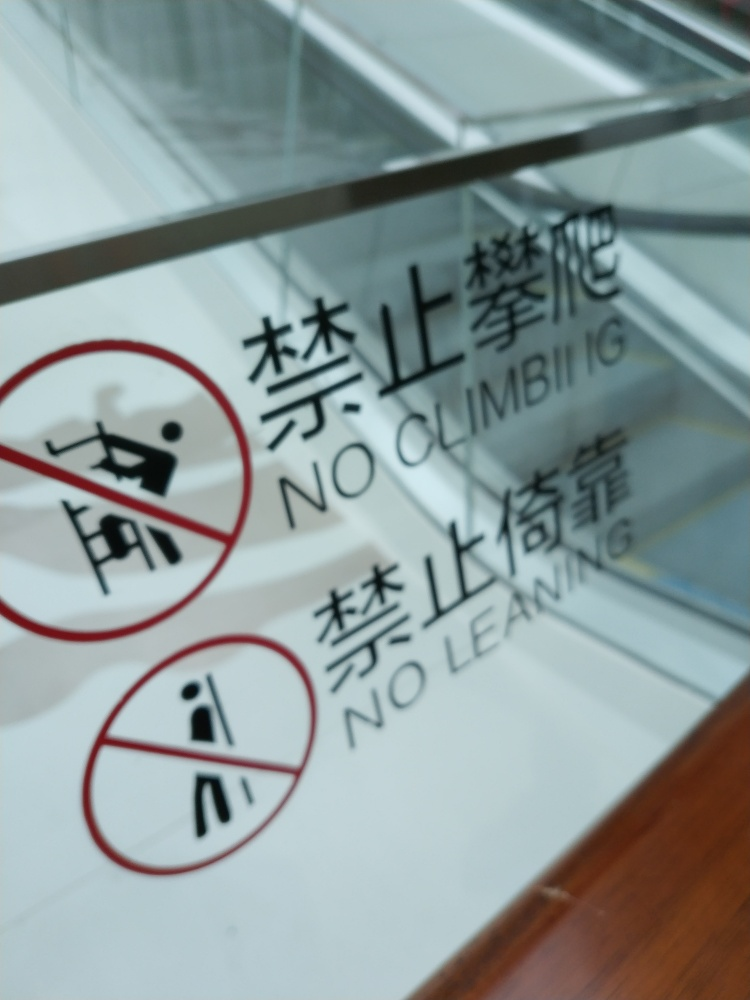How does the blurry quality of the photo affect the message of the sign? Despite the blurriness, the message of the sign remains clear due to the boldness and simplicity of the pictograms. Such designs are meant to be quickly understood at a glance, which is beneficial in safety communication where clarity is paramount. However, the blurriness could reduce the sign's effectiveness somewhat by making the text harder to read, potentially hindering comprehension for those who rely on the written instructions. 